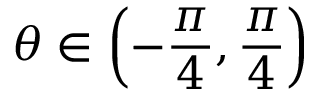Convert formula to latex. <formula><loc_0><loc_0><loc_500><loc_500>\theta \in \left ( { - \frac { \pi } { 4 } , \frac { \pi } { 4 } } \right )</formula> 